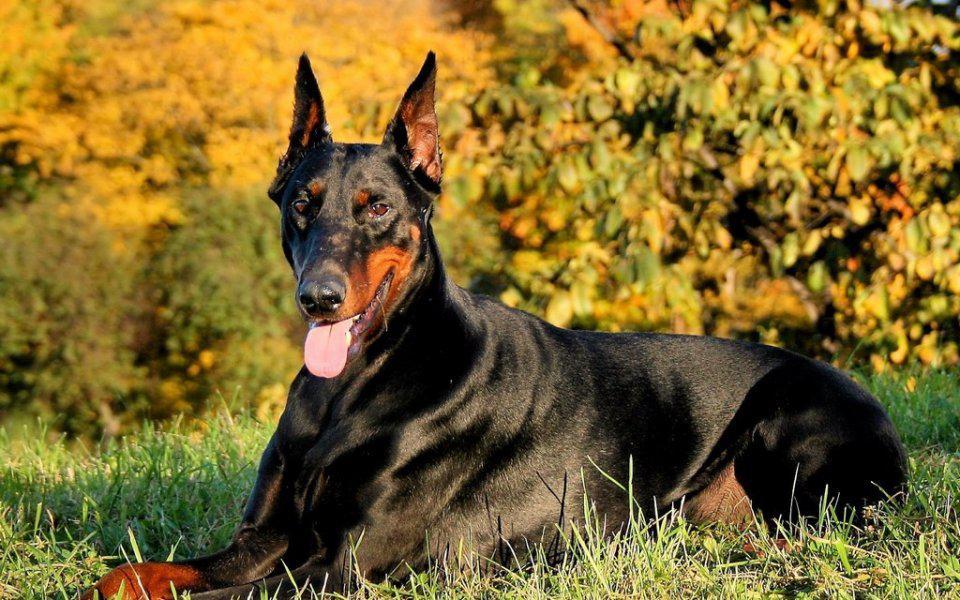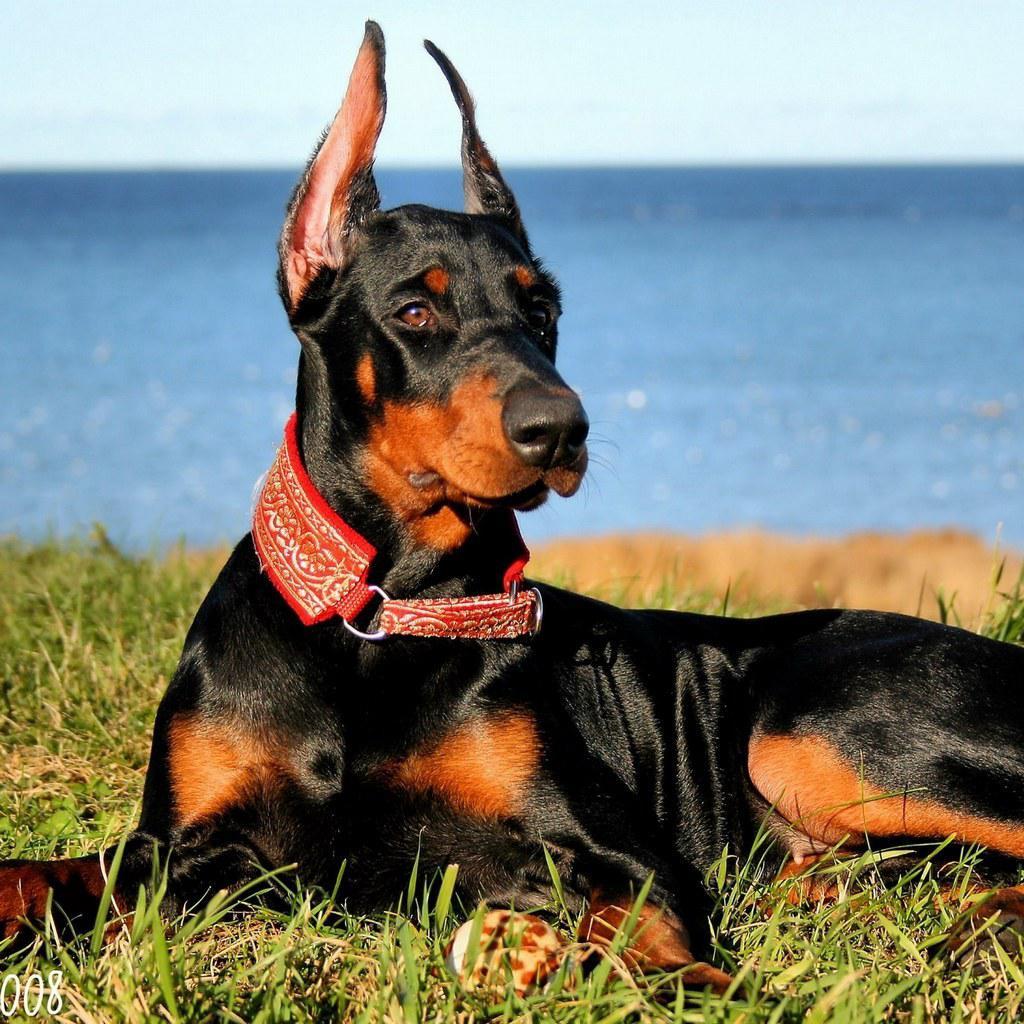The first image is the image on the left, the second image is the image on the right. Assess this claim about the two images: "The right image contains exactly two dogs.". Correct or not? Answer yes or no. No. The first image is the image on the left, the second image is the image on the right. Given the left and right images, does the statement "A minimum of 3 dogs are present" hold true? Answer yes or no. No. 